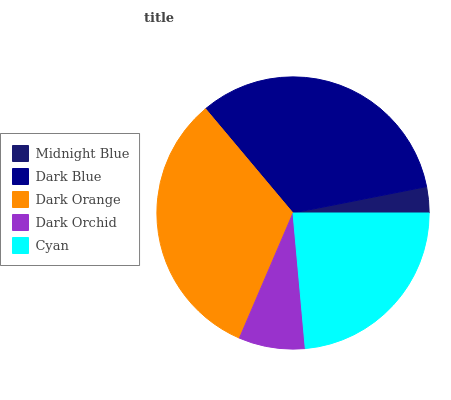Is Midnight Blue the minimum?
Answer yes or no. Yes. Is Dark Blue the maximum?
Answer yes or no. Yes. Is Dark Orange the minimum?
Answer yes or no. No. Is Dark Orange the maximum?
Answer yes or no. No. Is Dark Blue greater than Dark Orange?
Answer yes or no. Yes. Is Dark Orange less than Dark Blue?
Answer yes or no. Yes. Is Dark Orange greater than Dark Blue?
Answer yes or no. No. Is Dark Blue less than Dark Orange?
Answer yes or no. No. Is Cyan the high median?
Answer yes or no. Yes. Is Cyan the low median?
Answer yes or no. Yes. Is Dark Orchid the high median?
Answer yes or no. No. Is Midnight Blue the low median?
Answer yes or no. No. 